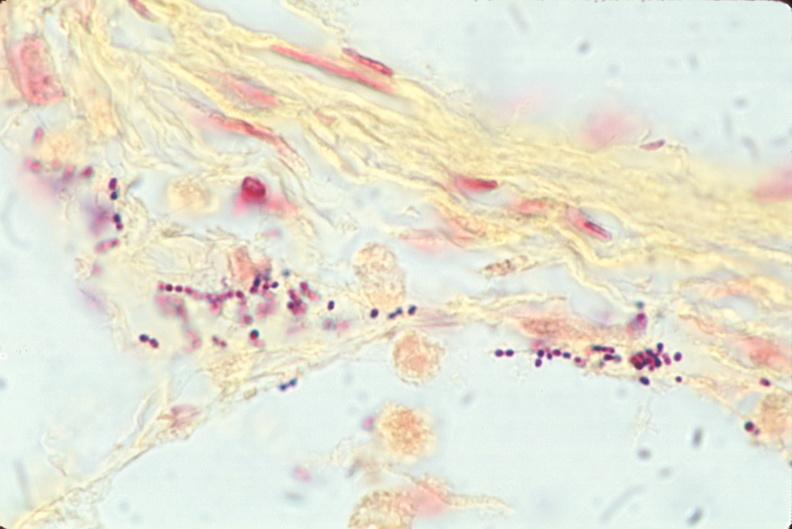s respiratory present?
Answer the question using a single word or phrase. Yes 